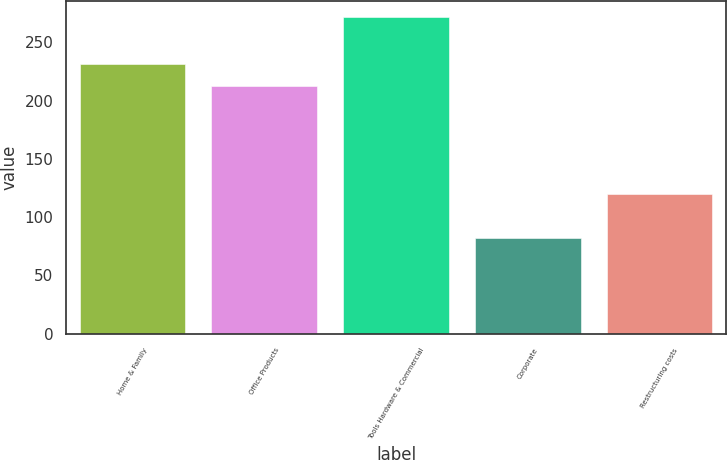Convert chart. <chart><loc_0><loc_0><loc_500><loc_500><bar_chart><fcel>Home & Family<fcel>Office Products<fcel>Tools Hardware & Commercial<fcel>Corporate<fcel>Restructuring costs<nl><fcel>231.38<fcel>212.4<fcel>271.7<fcel>81.9<fcel>120.3<nl></chart> 